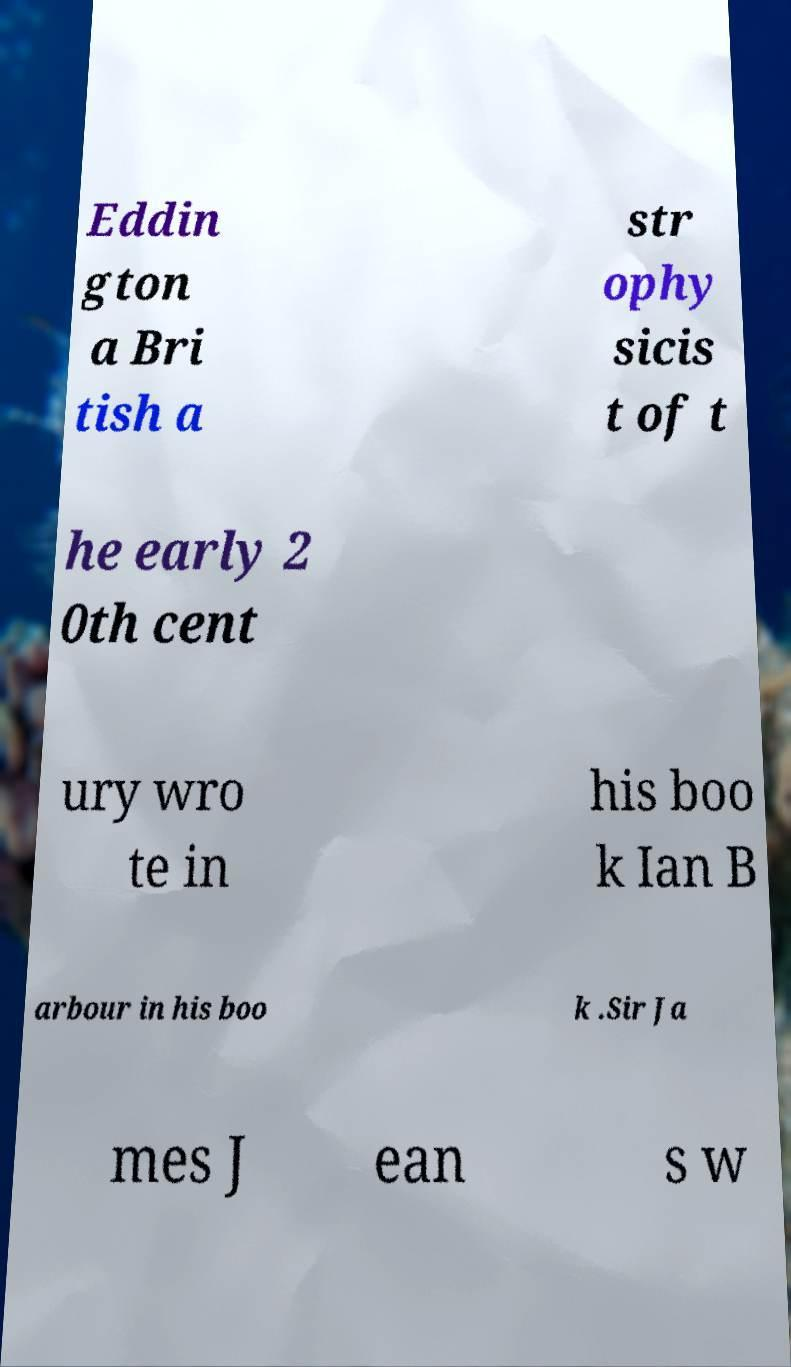Please read and relay the text visible in this image. What does it say? Eddin gton a Bri tish a str ophy sicis t of t he early 2 0th cent ury wro te in his boo k Ian B arbour in his boo k .Sir Ja mes J ean s w 